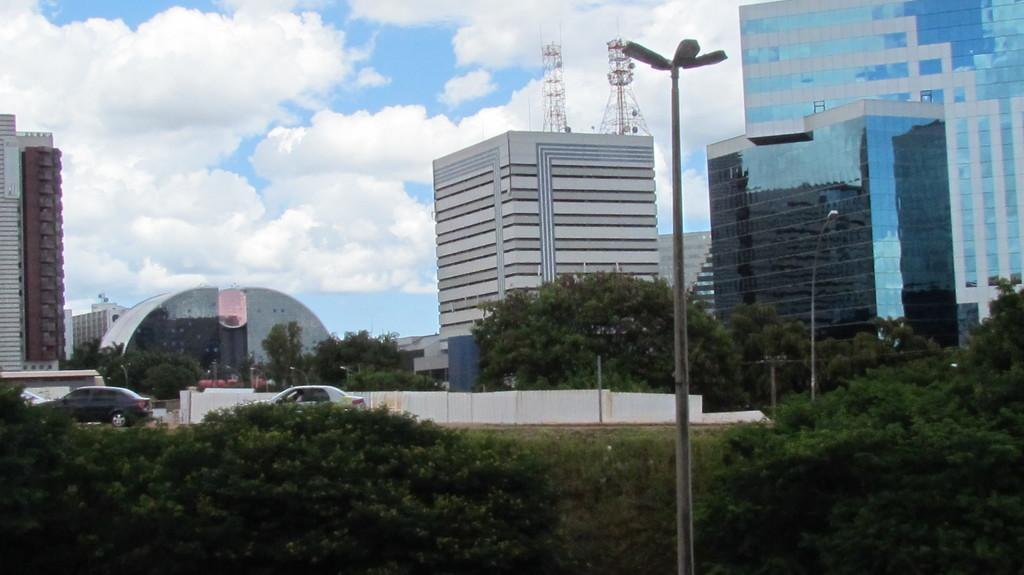What type of structures can be seen in the image? There are buildings, poles, and towers in the image. What else can be seen in the image besides structures? There are vehicles, lights, trees, and a wall in the image. What is visible in the background of the image? The sky is visible in the background of the image, with clouds present. Where is the sofa located in the image? There is no sofa present in the image. What type of railway is visible in the image? There is no railway present in the image. 